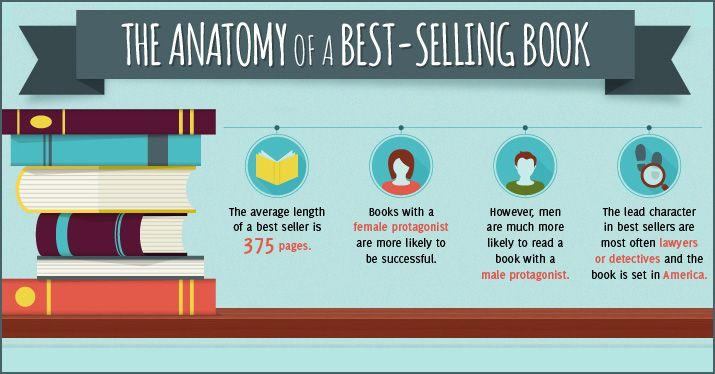Highlight a few significant elements in this photo. There are 7 books mentioned in this infographic. There are two books with a yellow color in the infographic. 